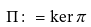Convert formula to latex. <formula><loc_0><loc_0><loc_500><loc_500>\Pi \colon = \ker \pi</formula> 